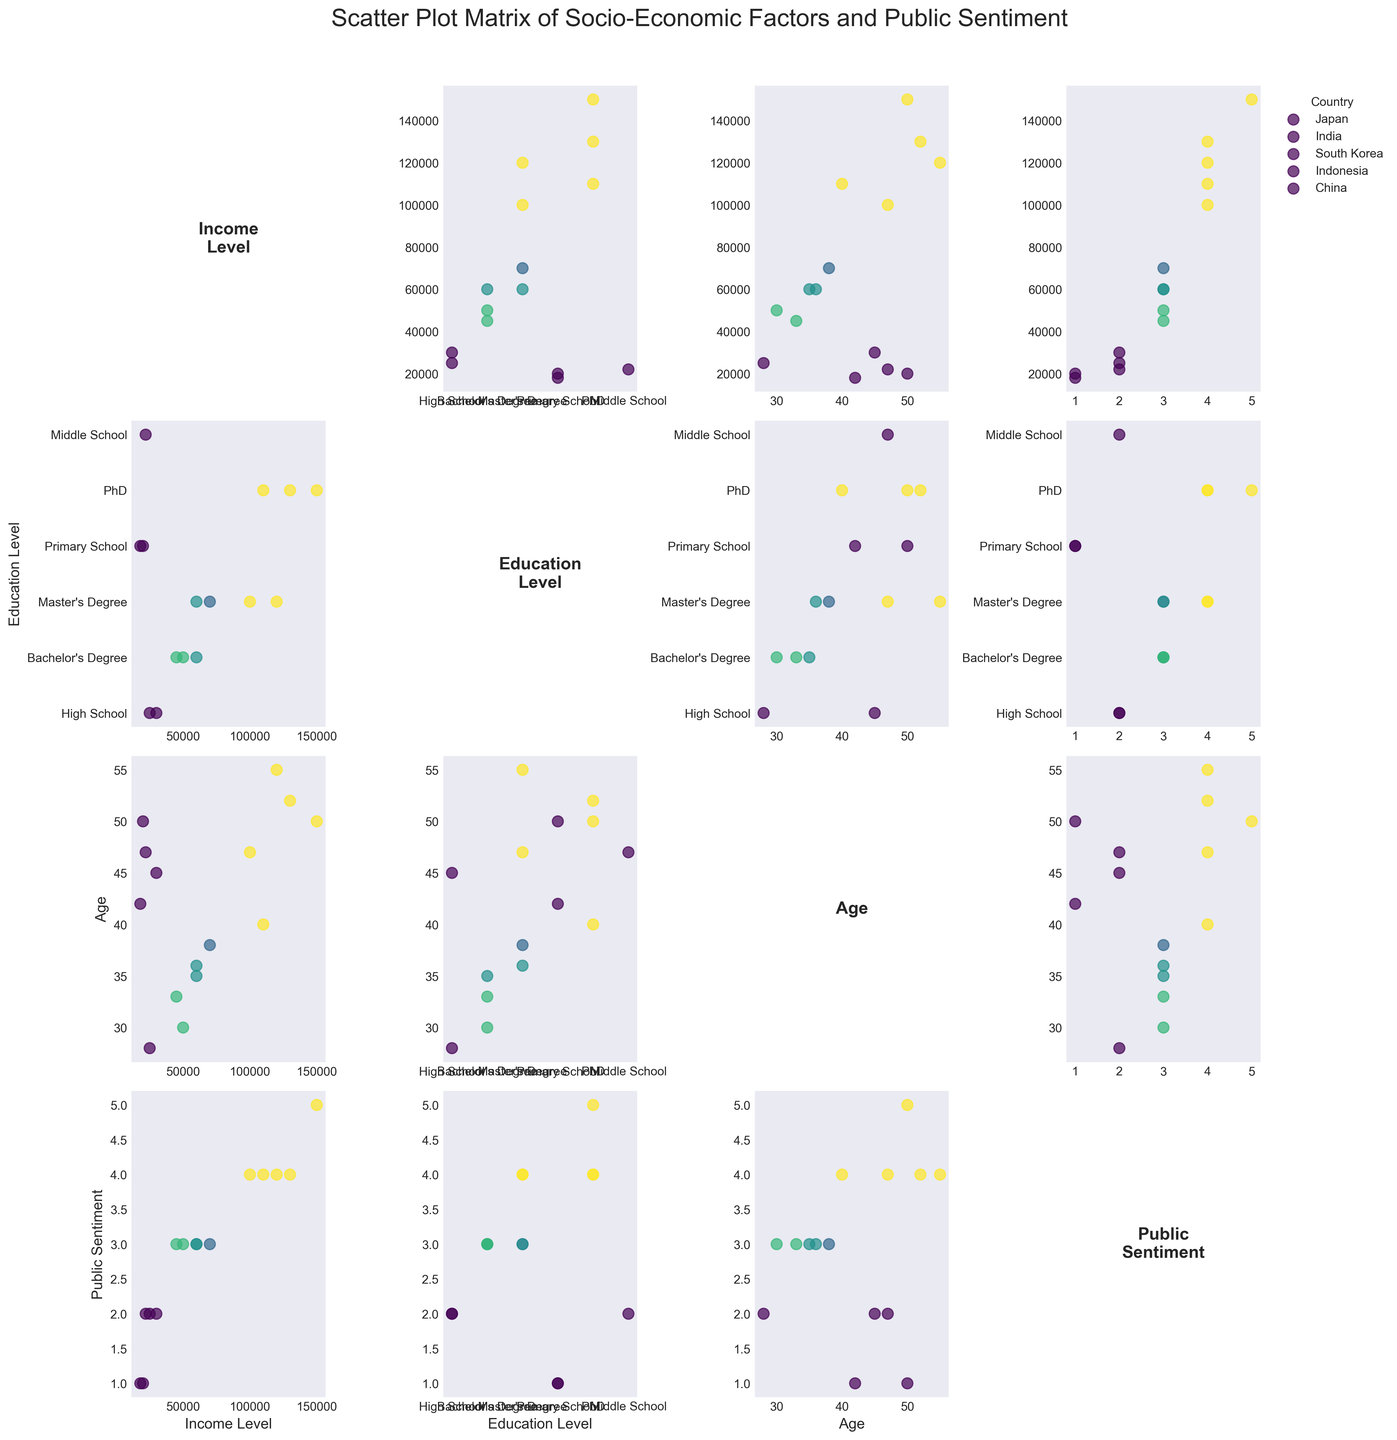What is the title of the scatter plot matrix? The title is displayed at the top of the figure.
Answer: Scatter Plot Matrix of Socio-Economic Factors and Public Sentiment How many countries are represented in the figure? The legend in the scatter plot matrix indicates the number of unique countries represented.
Answer: Five Which country has the highest public sentiment score among the high-income groups? By examining the scatter points labeled for each country within the 'Public Sentiment' axis, South Korea has the highest public sentiment score in the high-income group.
Answer: South Korea What is the age range of individuals with a positive public sentiment in Japan? In the scatter plot comparing 'Age' and 'Public Sentiment' for Japan, the individual with positive sentiment falls within the 'High-Income' group with an age of 55.
Answer: 55 Among the middle-income groups, which country has the highest education level representative? By examining the scatter points in the matrix comparing 'Education Level' and 'Income Level' for the middle-income group, South Korea has the highest representative with a Master's degree.
Answer: South Korea What is the trend in public sentiment toward Western intervention as education level increases? By observing the scatter plots comparing 'Public Sentiment' and 'Education Level', a general trend of increasing positive sentiment with higher education levels is evident, especially in countries like South Korea and China.
Answer: Positive sentiment increases with higher education level Which socio-economic group in India shows the most negative sentiment toward Western intervention? By looking at the scatter plot matrix in the 'Public Sentiment' and 'Income Level' section for India, it can be noted that the low-income group visibly shows a very negative sentiment.
Answer: Low-Income How does Japan's public sentiment compare to China's at similar income levels? By comparing the scatter points of 'Public Sentiment' and 'Income Level' for Japan and China, both countries exhibit similar neutral sentiment at middle income but diverge at high income, where China’s sentiment is positive, and Japan's is also positive.
Answer: Similar at middle income and both positive at high income What is the typical public sentiment score for middle-income respondents across all countries? By examining the 'Public Sentiment' for middle-income groups across different scatter plots, the typical sentiment score hovers around neutral.
Answer: Neutral In which country do low-income groups have the highest education level? By observing the scatter plot comparing 'Income Level' and 'Education Level', South Korea's low-income group has a representative with the highest education level (High School) among low-income groups.
Answer: South Korea 